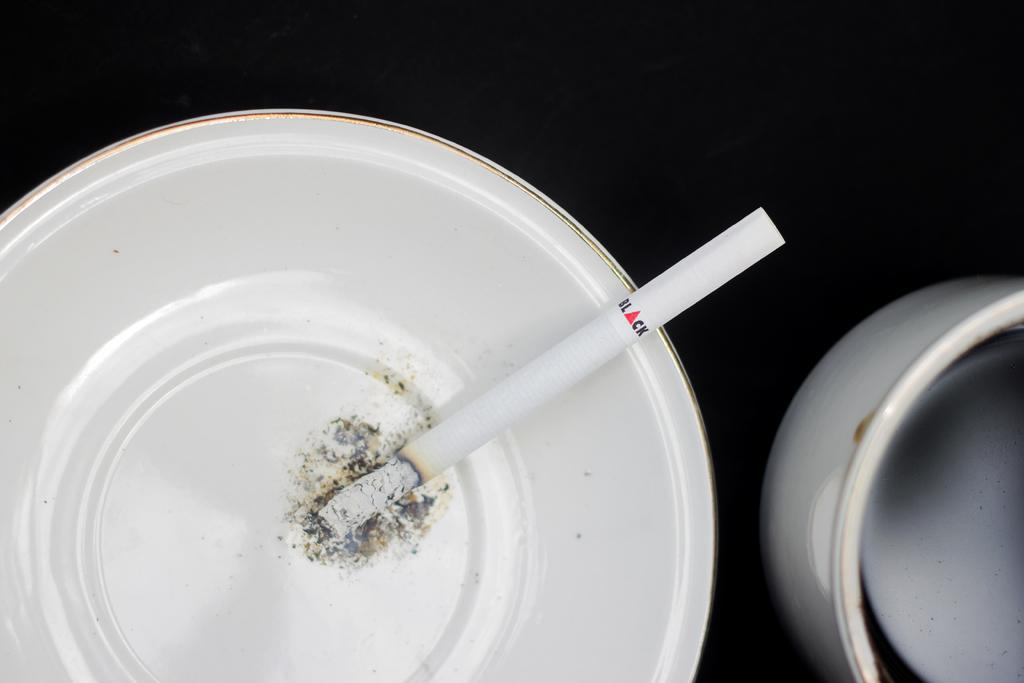What object is the main focus of the image? There is a cigar in the image. How is the cigar positioned in the image? The cigar is in a plate. What type of liquid can be seen in the image? There is no liquid present in the image; it features a cigar in a plate. What type of rub can be seen on the cigar in the image? There is no rub visible on the cigar in the image. 